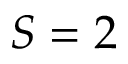<formula> <loc_0><loc_0><loc_500><loc_500>S = 2</formula> 